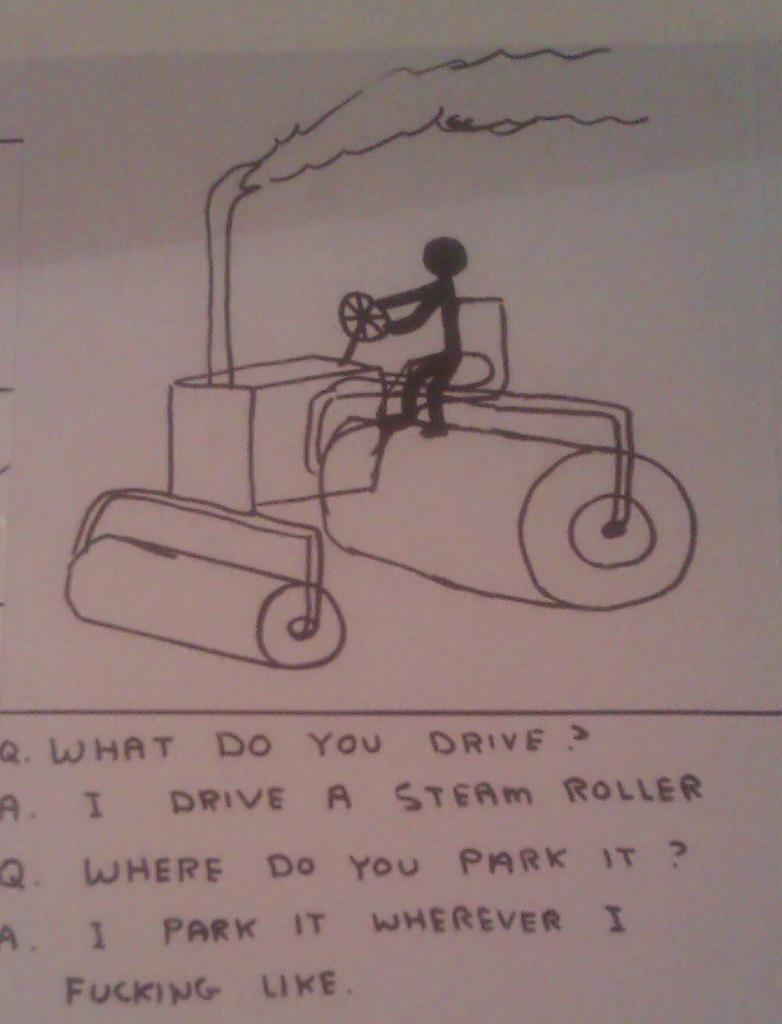What is present on the paper in the image? The paper has a drawing on it and text on it. Can you describe the drawing on the paper? Unfortunately, the facts provided do not give a detailed description of the drawing. What type of content is included in the text on the paper? The facts provided do not specify the content of the text on the paper. How many children are depicted in the drawing on the paper? There is no information about children or any drawing details in the provided facts. 